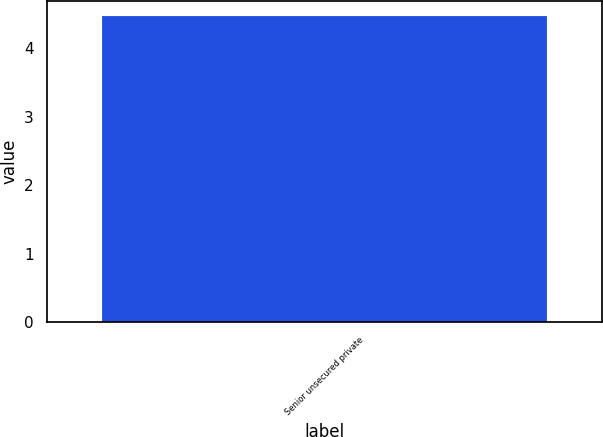<chart> <loc_0><loc_0><loc_500><loc_500><bar_chart><fcel>Senior unsecured private<nl><fcel>4.47<nl></chart> 